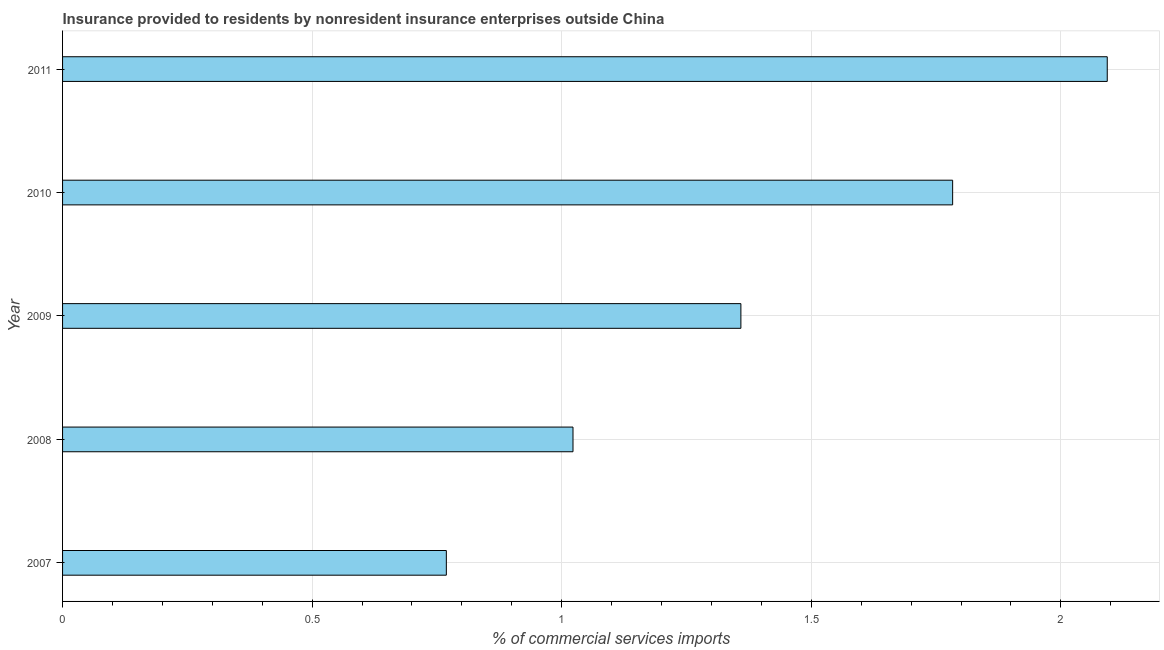Does the graph contain grids?
Keep it short and to the point. Yes. What is the title of the graph?
Provide a short and direct response. Insurance provided to residents by nonresident insurance enterprises outside China. What is the label or title of the X-axis?
Your answer should be very brief. % of commercial services imports. What is the insurance provided by non-residents in 2008?
Give a very brief answer. 1.02. Across all years, what is the maximum insurance provided by non-residents?
Ensure brevity in your answer.  2.09. Across all years, what is the minimum insurance provided by non-residents?
Your answer should be compact. 0.77. What is the sum of the insurance provided by non-residents?
Give a very brief answer. 7.03. What is the difference between the insurance provided by non-residents in 2010 and 2011?
Make the answer very short. -0.31. What is the average insurance provided by non-residents per year?
Provide a short and direct response. 1.41. What is the median insurance provided by non-residents?
Provide a short and direct response. 1.36. In how many years, is the insurance provided by non-residents greater than 0.9 %?
Make the answer very short. 4. Do a majority of the years between 2009 and 2007 (inclusive) have insurance provided by non-residents greater than 0.5 %?
Your response must be concise. Yes. What is the ratio of the insurance provided by non-residents in 2007 to that in 2008?
Offer a very short reply. 0.75. Is the difference between the insurance provided by non-residents in 2010 and 2011 greater than the difference between any two years?
Your response must be concise. No. What is the difference between the highest and the second highest insurance provided by non-residents?
Provide a succinct answer. 0.31. What is the difference between the highest and the lowest insurance provided by non-residents?
Give a very brief answer. 1.32. In how many years, is the insurance provided by non-residents greater than the average insurance provided by non-residents taken over all years?
Provide a succinct answer. 2. Are all the bars in the graph horizontal?
Your answer should be very brief. Yes. How many years are there in the graph?
Your response must be concise. 5. What is the difference between two consecutive major ticks on the X-axis?
Ensure brevity in your answer.  0.5. What is the % of commercial services imports of 2007?
Offer a terse response. 0.77. What is the % of commercial services imports of 2008?
Provide a short and direct response. 1.02. What is the % of commercial services imports in 2009?
Your answer should be compact. 1.36. What is the % of commercial services imports of 2010?
Keep it short and to the point. 1.78. What is the % of commercial services imports of 2011?
Provide a short and direct response. 2.09. What is the difference between the % of commercial services imports in 2007 and 2008?
Your answer should be compact. -0.25. What is the difference between the % of commercial services imports in 2007 and 2009?
Provide a short and direct response. -0.59. What is the difference between the % of commercial services imports in 2007 and 2010?
Provide a succinct answer. -1.01. What is the difference between the % of commercial services imports in 2007 and 2011?
Provide a short and direct response. -1.32. What is the difference between the % of commercial services imports in 2008 and 2009?
Make the answer very short. -0.34. What is the difference between the % of commercial services imports in 2008 and 2010?
Your answer should be compact. -0.76. What is the difference between the % of commercial services imports in 2008 and 2011?
Your response must be concise. -1.07. What is the difference between the % of commercial services imports in 2009 and 2010?
Ensure brevity in your answer.  -0.42. What is the difference between the % of commercial services imports in 2009 and 2011?
Keep it short and to the point. -0.73. What is the difference between the % of commercial services imports in 2010 and 2011?
Provide a short and direct response. -0.31. What is the ratio of the % of commercial services imports in 2007 to that in 2008?
Your answer should be very brief. 0.75. What is the ratio of the % of commercial services imports in 2007 to that in 2009?
Give a very brief answer. 0.57. What is the ratio of the % of commercial services imports in 2007 to that in 2010?
Offer a very short reply. 0.43. What is the ratio of the % of commercial services imports in 2007 to that in 2011?
Offer a very short reply. 0.37. What is the ratio of the % of commercial services imports in 2008 to that in 2009?
Give a very brief answer. 0.75. What is the ratio of the % of commercial services imports in 2008 to that in 2010?
Provide a short and direct response. 0.57. What is the ratio of the % of commercial services imports in 2008 to that in 2011?
Your response must be concise. 0.49. What is the ratio of the % of commercial services imports in 2009 to that in 2010?
Make the answer very short. 0.76. What is the ratio of the % of commercial services imports in 2009 to that in 2011?
Provide a succinct answer. 0.65. What is the ratio of the % of commercial services imports in 2010 to that in 2011?
Your answer should be compact. 0.85. 